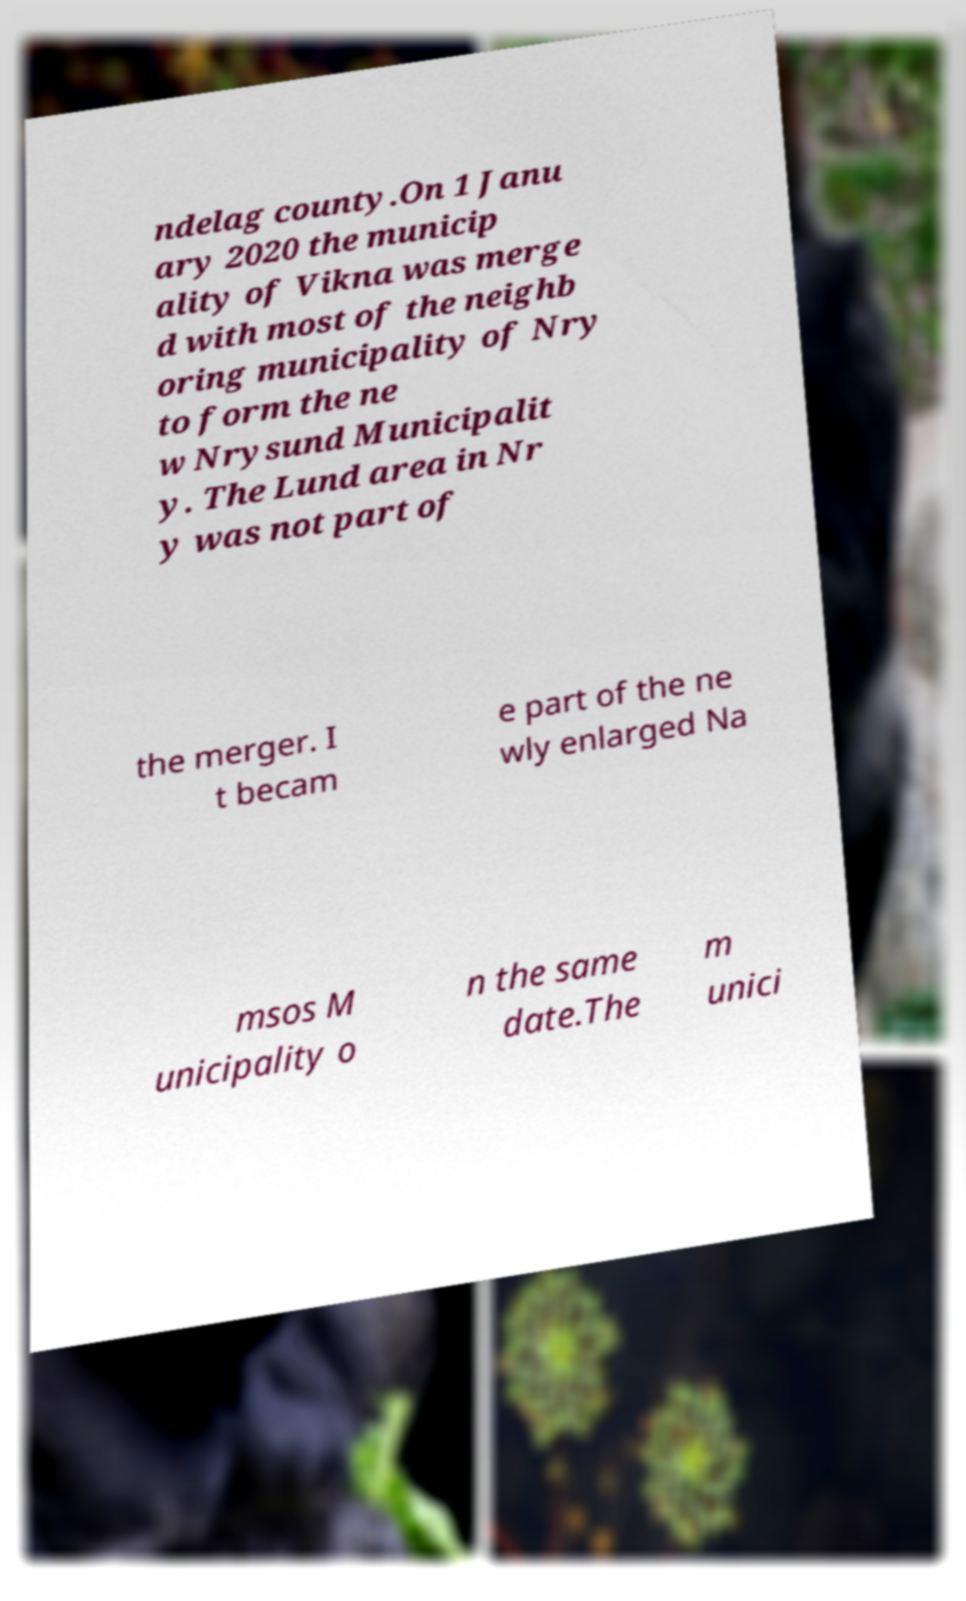Could you extract and type out the text from this image? ndelag county.On 1 Janu ary 2020 the municip ality of Vikna was merge d with most of the neighb oring municipality of Nry to form the ne w Nrysund Municipalit y. The Lund area in Nr y was not part of the merger. I t becam e part of the ne wly enlarged Na msos M unicipality o n the same date.The m unici 